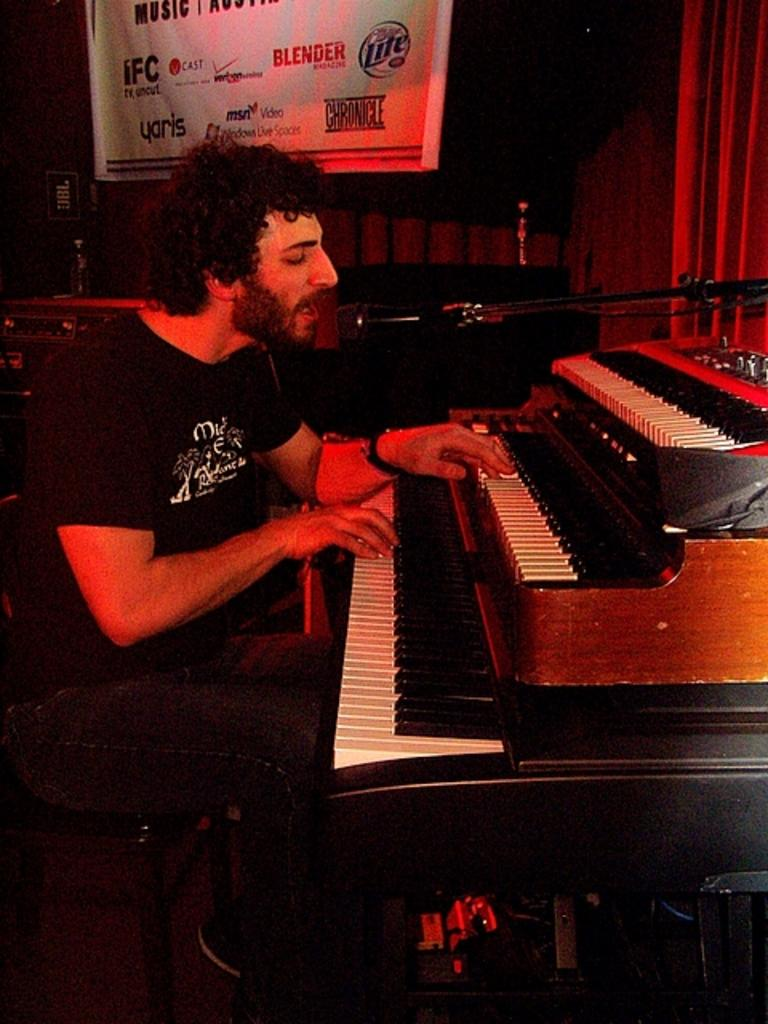Who is the person in the image? There is a man in the image. What is the man doing in the image? The man is sitting in a chair and playing the piano. What is located behind the man in the image? There is a poster and a wall in the background of the image. How does the man maintain a quiet environment while playing the piano in the image? The image does not provide information about the volume of the piano playing or the presence of a quiet environment. 